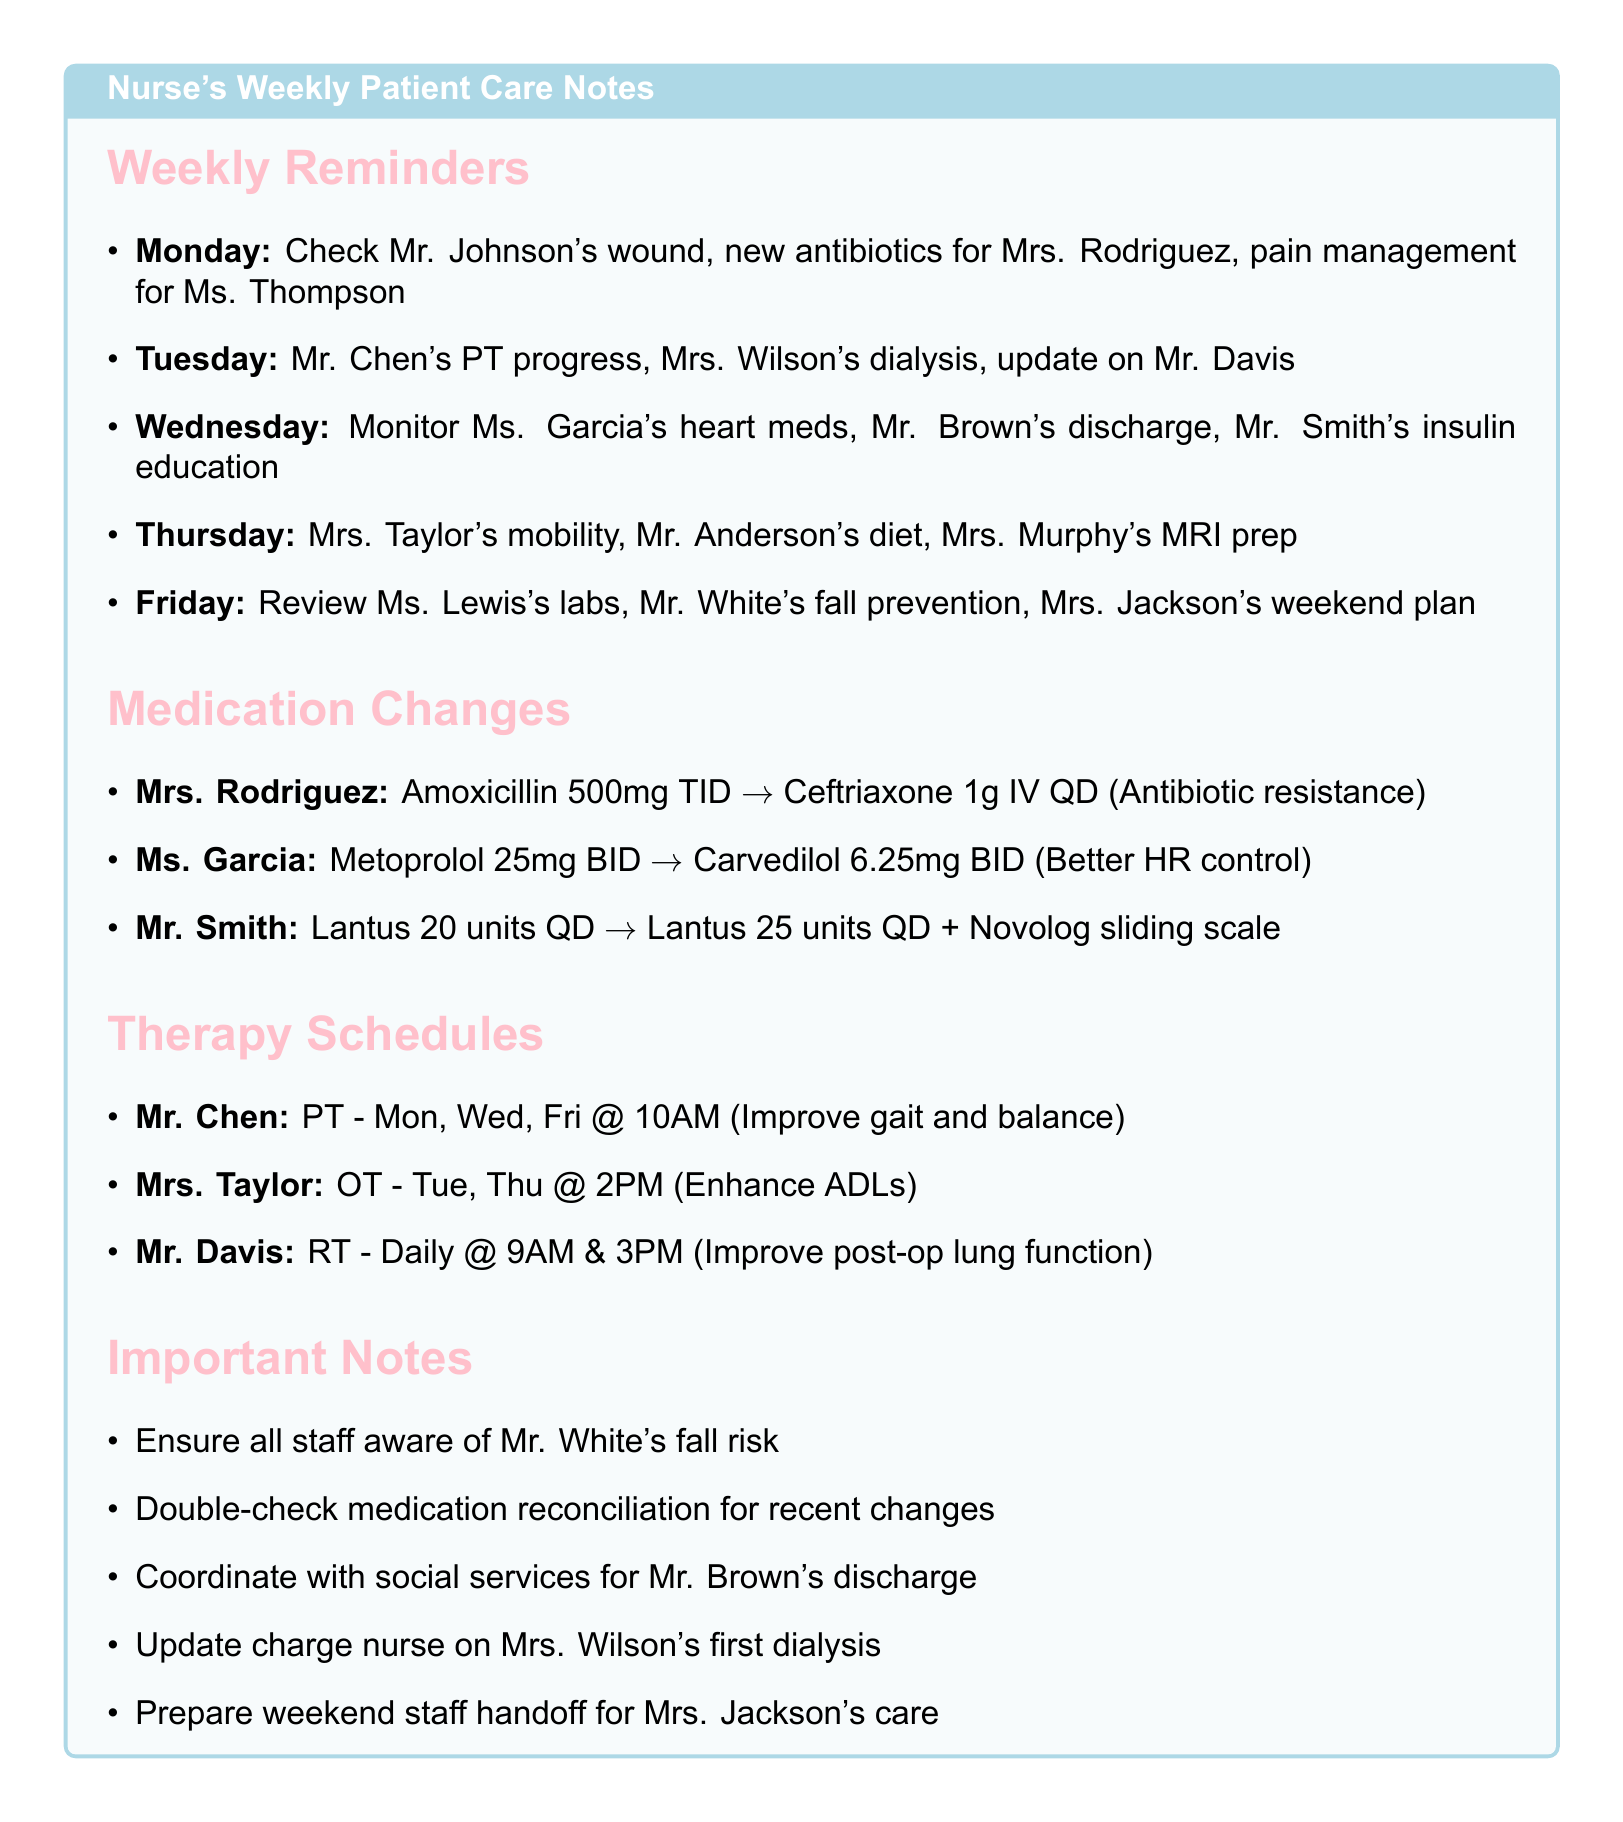What tasks are scheduled for Wednesday? The tasks for Wednesday include monitoring Ms. Garcia's heart meds, Mr. Brown's discharge, and Mr. Smith's insulin education.
Answer: Monitor Ms. Garcia's heart meds, Mr. Brown's discharge, Mr. Smith's insulin education What is the new medication for Mrs. Rodriguez? The document specifies the new medication for Mrs. Rodriguez as Ceftriaxone 1g IV QD, changing from Amoxicillin 500mg TID due to antibiotic resistance.
Answer: Ceftriaxone 1g IV QD When is Mr. Chen's physical therapy scheduled? Mr. Chen's therapy schedule includes physical therapy on Monday, Wednesday, and Friday at 10:00 AM to improve gait and balance.
Answer: Monday, Wednesday, Friday at 10:00 AM What is the reason for Mr. Smith's medication change? The reason for the medication change for Mr. Smith is to improve glucose management with an adjustment in insulin regimen.
Answer: Improved glucose management What important note relates to Mr. White? One of the important notes emphasizes ensuring all staff are aware of Mr. White's fall risk assessment.
Answer: Fall risk assessment What therapy schedule does Mrs. Taylor have? Mrs. Taylor's occupational therapy is scheduled for Tuesday and Thursday at 2:00 PM aimed at enhancing activities of daily living.
Answer: Tuesday, Thursday at 2:00 PM How many times a day does Mr. Davis receive respiratory therapy? The document states that Mr. Davis receives respiratory therapy twice a day at 9:00 AM and 3:00 PM post-surgery.
Answer: Twice a day What should be double-checked regarding recent medication changes? The document notes that medication reconciliation should be double-checked for all patients who have had recent changes.
Answer: Medication reconciliation What is the goal of Mr. Chen's therapy? The goal of Mr. Chen's physical therapy is to improve his gait and balance.
Answer: Improve gait and balance 